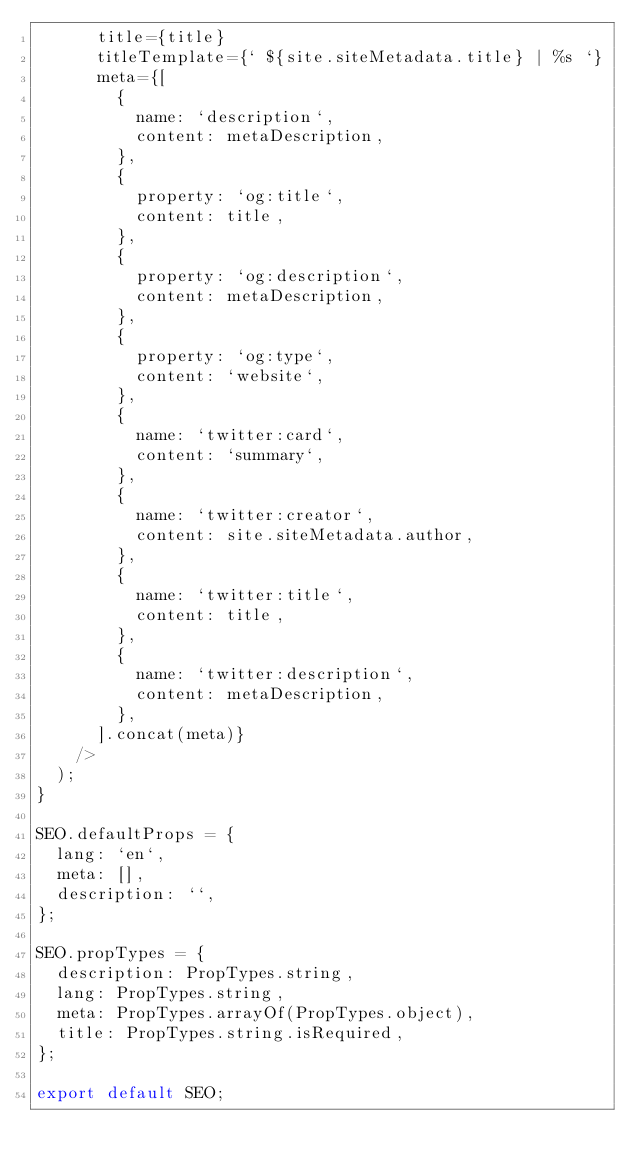Convert code to text. <code><loc_0><loc_0><loc_500><loc_500><_JavaScript_>      title={title}
      titleTemplate={` ${site.siteMetadata.title} | %s `}
      meta={[
        {
          name: `description`,
          content: metaDescription,
        },
        {
          property: `og:title`,
          content: title,
        },
        {
          property: `og:description`,
          content: metaDescription,
        },
        {
          property: `og:type`,
          content: `website`,
        },
        {
          name: `twitter:card`,
          content: `summary`,
        },
        {
          name: `twitter:creator`,
          content: site.siteMetadata.author,
        },
        {
          name: `twitter:title`,
          content: title,
        },
        {
          name: `twitter:description`,
          content: metaDescription,
        },
      ].concat(meta)}
    />
  );
}

SEO.defaultProps = {
  lang: `en`,
  meta: [],
  description: ``,
};

SEO.propTypes = {
  description: PropTypes.string,
  lang: PropTypes.string,
  meta: PropTypes.arrayOf(PropTypes.object),
  title: PropTypes.string.isRequired,
};

export default SEO;
</code> 